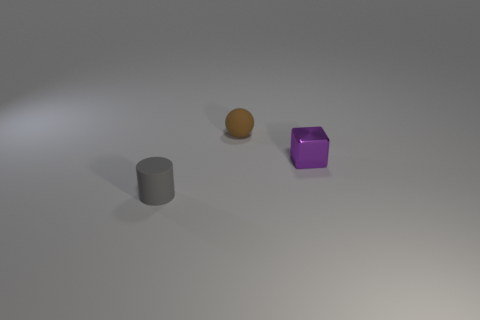Add 2 brown shiny spheres. How many objects exist? 5 Subtract all cylinders. How many objects are left? 2 Subtract 0 cyan cylinders. How many objects are left? 3 Subtract all red cubes. Subtract all cyan spheres. How many cubes are left? 1 Subtract all matte cylinders. Subtract all brown matte balls. How many objects are left? 1 Add 3 gray matte things. How many gray matte things are left? 4 Add 3 brown balls. How many brown balls exist? 4 